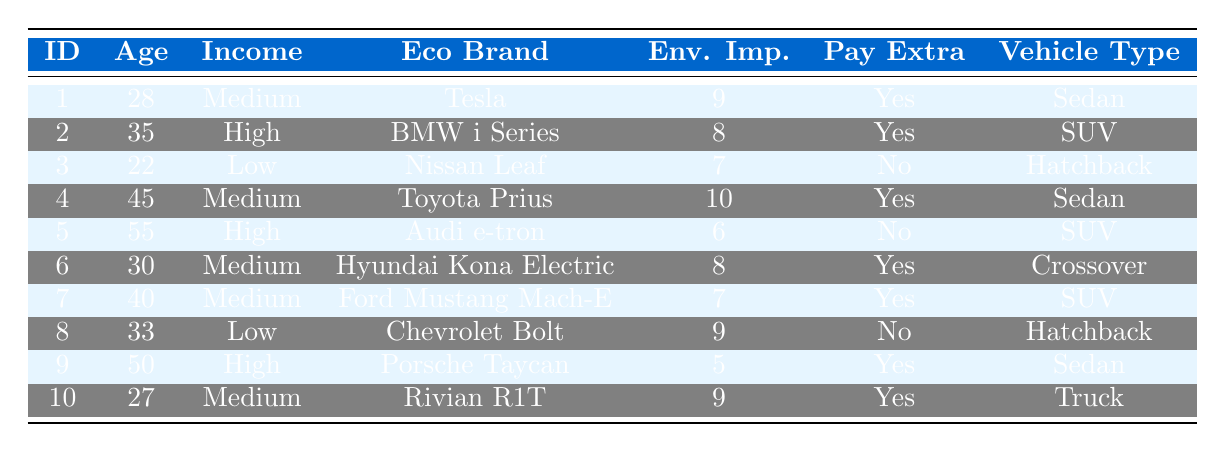What is the preferred eco brand of respondent 4? According to the table, respondent 4 has chosen "Toyota Prius" as their preferred eco brand.
Answer: Toyota Prius How many respondents are willing to pay extra for an eco-friendly vehicle? The table shows that respondents 1, 2, 4, 6, 7, 9, and 10 are willing to pay extra. Count these respondents gives a total of 7.
Answer: 7 What is the maximum importance of the environment rating among all respondents? Looking through the table, the highest rating for importance of the environment is 10, which belongs to respondent 4.
Answer: 10 Does respondent 3 have a high income level? Respondent 3 is categorized as having a "Low" income level according to the table, so the answer is no.
Answer: No What is the average age of respondents who are willing to pay extra? The ages of respondents willing to pay extra are 28, 35, 45, 30, 40, 50, and 27. The total is 28 + 35 + 45 + 30 + 40 + 50 + 27 = 255 and there are 7 respondents, giving an average of 255 / 7 = 36.43.
Answer: 36.43 Which preferred eco brand has the highest importance of environment rating? The table shows respondent 4 with "Toyota Prius" at a rating of 10, which is the highest rating, so that is the highest rated eco brand in the table.
Answer: Toyota Prius How many respondents prefer SUVs as their vehicle type? The table lists respondents 2, 5, and 7 as preferring SUVs, leading to a total of 3 respondents preferring SUVs.
Answer: 3 Does any respondent with a high income level prefer a Hatchback? From the table, respondents with a high income level are 2, 5, and 9, and none of them prefer a hatchback. Thus the answer is no.
Answer: No What is the importance of the environment rating for the preferred brand of the respondent who is 55 years old? Respondent 5 is 55 years old and prefers the "Audi e-tron" with an importance of environment rating of 6, according to the table.
Answer: 6 Which vehicle type is preferred by respondent 10? Respondent 10 has chosen "Truck" as their preferred vehicle type as stated in the table.
Answer: Truck 